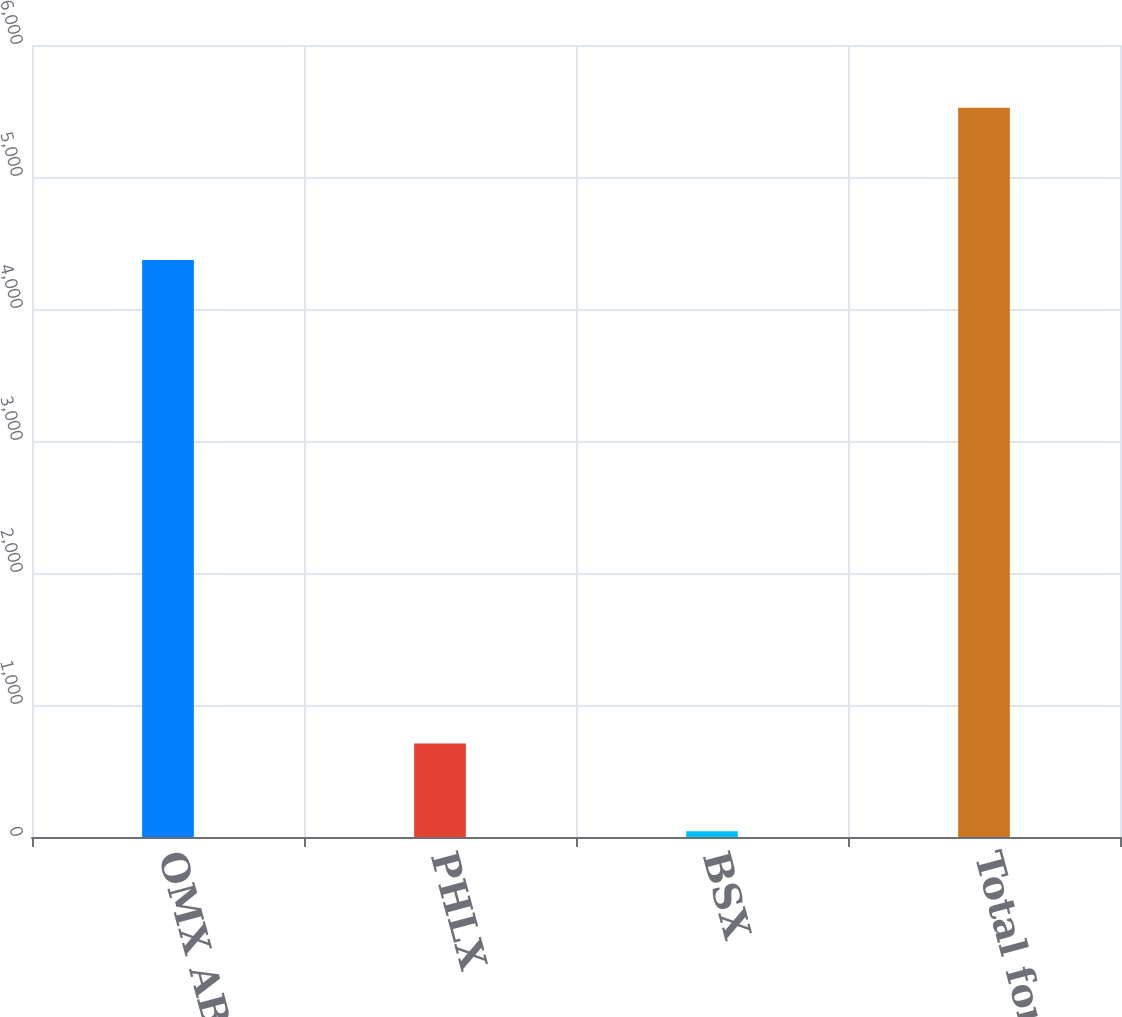Convert chart. <chart><loc_0><loc_0><loc_500><loc_500><bar_chart><fcel>OMX AB<fcel>PHLX<fcel>BSX<fcel>Total for 2008<nl><fcel>4371<fcel>708<fcel>43<fcel>5524<nl></chart> 